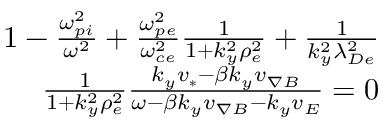Convert formula to latex. <formula><loc_0><loc_0><loc_500><loc_500>\begin{array} { r } { 1 - \frac { \omega _ { p i } ^ { 2 } } { \omega ^ { 2 } } + \frac { \omega _ { p e } ^ { 2 } } { \omega _ { c e } ^ { 2 } } \frac { 1 } { 1 + k _ { y } ^ { 2 } \rho _ { e } ^ { 2 } } + \frac { 1 } { k _ { y } ^ { 2 } \lambda _ { D e } ^ { 2 } } } \\ { \frac { 1 } { 1 + k _ { y } ^ { 2 } \rho _ { e } ^ { 2 } } \frac { k _ { y } v _ { * } - \beta k _ { y } v _ { \nabla B } } { \omega - \beta k _ { y } v _ { \nabla B } - k _ { y } v _ { E } } = 0 } \end{array}</formula> 